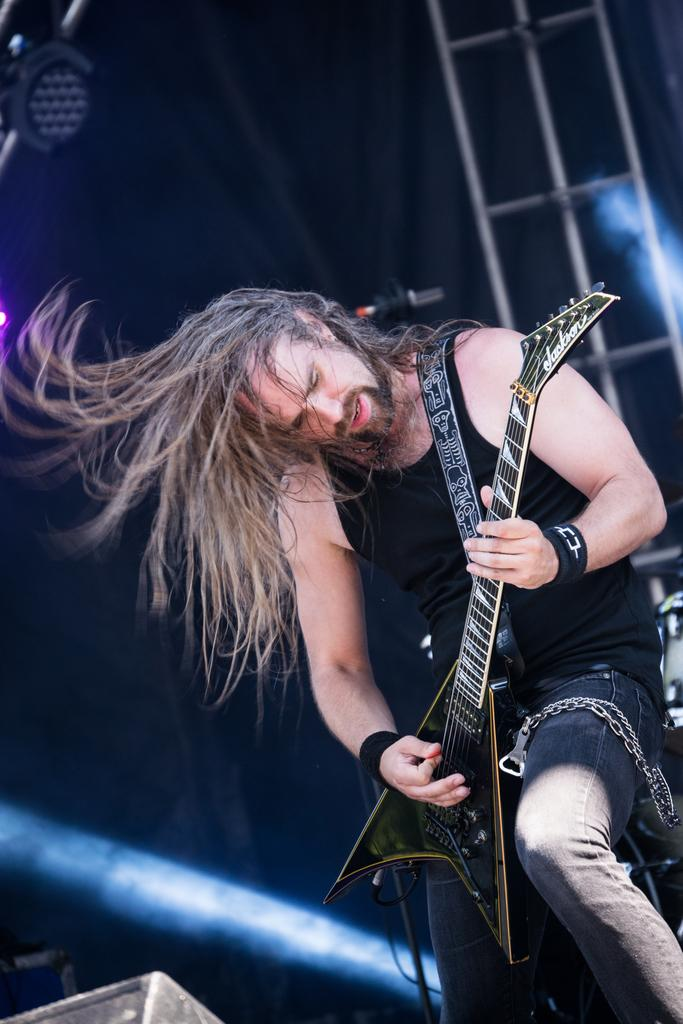What is the main subject of the image? The main subject of the image is a man. What is the man holding in the image? The man is holding a guitar in the image. What type of advice is the man giving in the image? There is no indication in the image that the man is giving advice, as the focus is on him holding a guitar. 